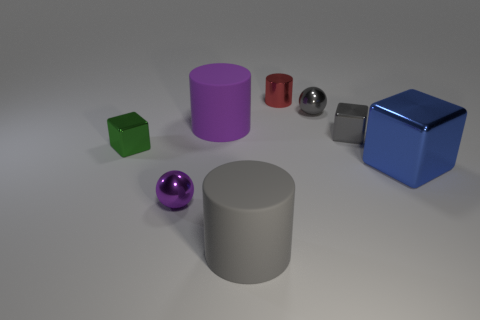What is the shape of the gray rubber thing?
Make the answer very short. Cylinder. There is a purple object that is the same size as the blue block; what is it made of?
Make the answer very short. Rubber. How many objects are large purple cylinders or rubber cylinders that are in front of the tiny green cube?
Your answer should be compact. 2. The blue block that is the same material as the tiny cylinder is what size?
Provide a short and direct response. Large. The large object to the right of the gray metal thing on the right side of the small gray shiny sphere is what shape?
Ensure brevity in your answer.  Cube. There is a shiny object that is right of the purple metal object and in front of the tiny green metal thing; what is its size?
Your response must be concise. Large. Is there a small red thing that has the same shape as the green metal thing?
Ensure brevity in your answer.  No. The tiny cylinder that is behind the small metallic cube that is to the right of the matte thing in front of the gray metallic cube is made of what material?
Offer a terse response. Metal. Are there any cyan metal cylinders of the same size as the purple sphere?
Offer a terse response. No. There is a object left of the tiny shiny ball on the left side of the red metallic cylinder; what is its color?
Your response must be concise. Green. 